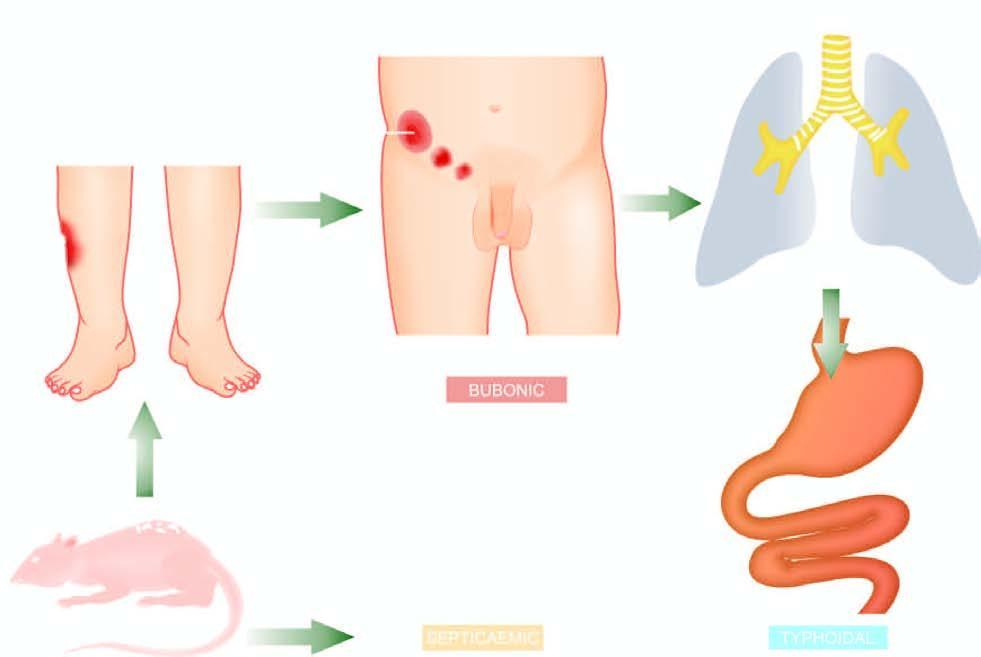do the alveolar capillaries plague?
Answer the question using a single word or phrase. No 